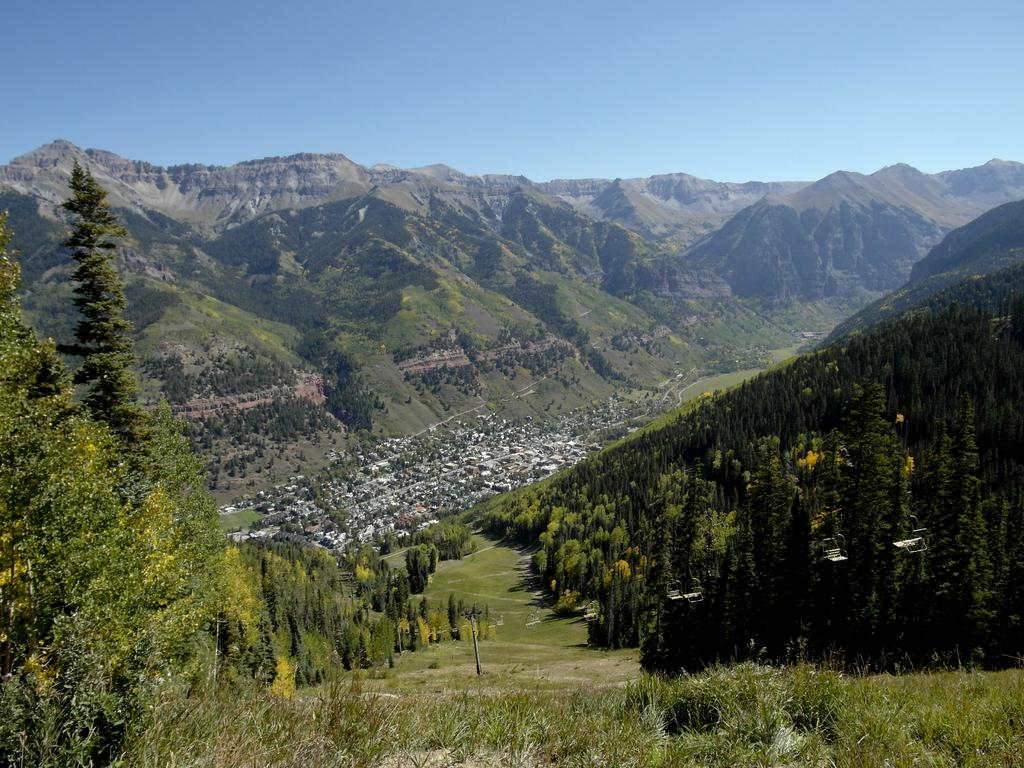What type of vegetation can be seen in the image? There are trees and plants in the image. What type of structures are visible in the image? There are houses in the image. What type of ground cover is present in the image? There is grass in the image. What type of geographical feature can be seen in the image? There are hills in the image. What part of the natural environment is visible in the image? The sky is visible in the image. What type of loaf can be seen in the image? There is no loaf present in the image; it features trees, plants, houses, grass, hills, and the sky. How does the taste of the trees in the image compare to that of the plants? Trees and plants do not have a taste, as they are not edible. 